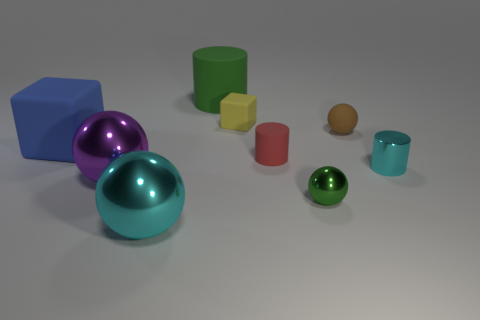Subtract 1 balls. How many balls are left? 3 Subtract all yellow balls. Subtract all yellow blocks. How many balls are left? 4 Subtract all cylinders. How many objects are left? 6 Subtract 1 cyan cylinders. How many objects are left? 8 Subtract all big blue blocks. Subtract all red matte objects. How many objects are left? 7 Add 2 green cylinders. How many green cylinders are left? 3 Add 7 large red rubber cylinders. How many large red rubber cylinders exist? 7 